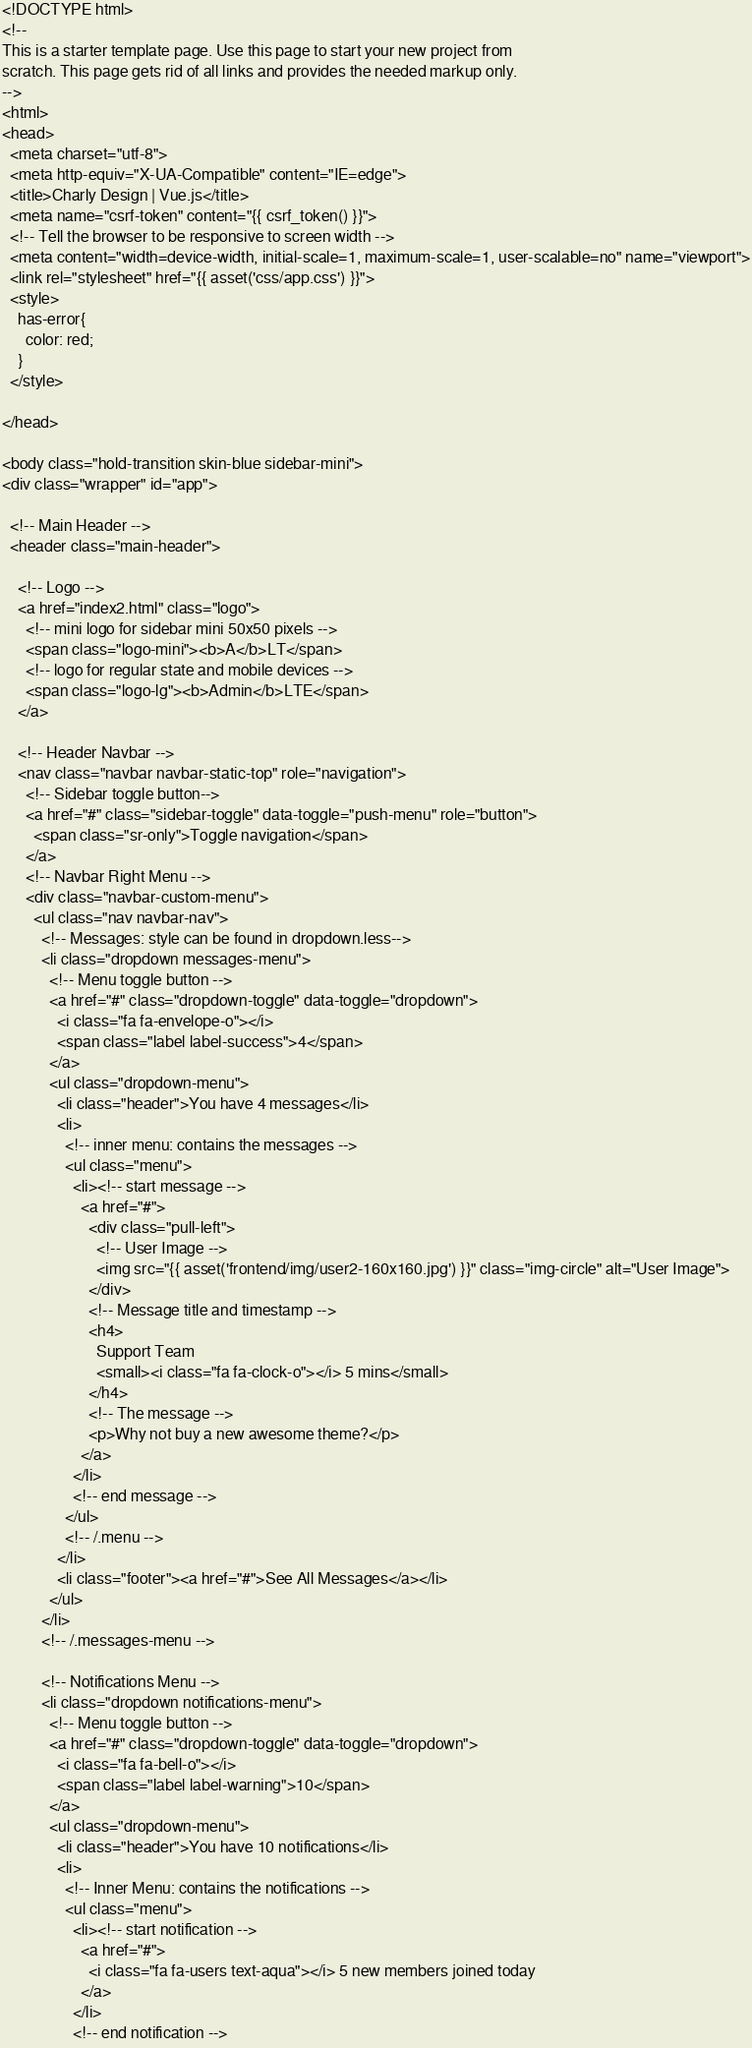<code> <loc_0><loc_0><loc_500><loc_500><_PHP_><!DOCTYPE html>
<!--
This is a starter template page. Use this page to start your new project from
scratch. This page gets rid of all links and provides the needed markup only.
-->
<html>
<head>
  <meta charset="utf-8">
  <meta http-equiv="X-UA-Compatible" content="IE=edge">
  <title>Charly Design | Vue.js</title>
  <meta name="csrf-token" content="{{ csrf_token() }}">
  <!-- Tell the browser to be responsive to screen width -->
  <meta content="width=device-width, initial-scale=1, maximum-scale=1, user-scalable=no" name="viewport">
  <link rel="stylesheet" href="{{ asset('css/app.css') }}">
  <style>
    has-error{
      color: red;
    }
  </style>
  
</head>

<body class="hold-transition skin-blue sidebar-mini">
<div class="wrapper" id="app">

  <!-- Main Header -->
  <header class="main-header">

    <!-- Logo -->
    <a href="index2.html" class="logo">
      <!-- mini logo for sidebar mini 50x50 pixels -->
      <span class="logo-mini"><b>A</b>LT</span>
      <!-- logo for regular state and mobile devices -->
      <span class="logo-lg"><b>Admin</b>LTE</span>
    </a>

    <!-- Header Navbar -->
    <nav class="navbar navbar-static-top" role="navigation">
      <!-- Sidebar toggle button-->
      <a href="#" class="sidebar-toggle" data-toggle="push-menu" role="button">
        <span class="sr-only">Toggle navigation</span>
      </a>
      <!-- Navbar Right Menu -->
      <div class="navbar-custom-menu">
        <ul class="nav navbar-nav">
          <!-- Messages: style can be found in dropdown.less-->
          <li class="dropdown messages-menu">
            <!-- Menu toggle button -->
            <a href="#" class="dropdown-toggle" data-toggle="dropdown">
              <i class="fa fa-envelope-o"></i>
              <span class="label label-success">4</span>
            </a>
            <ul class="dropdown-menu">
              <li class="header">You have 4 messages</li>
              <li>
                <!-- inner menu: contains the messages -->
                <ul class="menu">
                  <li><!-- start message -->
                    <a href="#">
                      <div class="pull-left">
                        <!-- User Image -->
                        <img src="{{ asset('frontend/img/user2-160x160.jpg') }}" class="img-circle" alt="User Image">
                      </div>
                      <!-- Message title and timestamp -->
                      <h4>
                        Support Team
                        <small><i class="fa fa-clock-o"></i> 5 mins</small>
                      </h4>
                      <!-- The message -->
                      <p>Why not buy a new awesome theme?</p>
                    </a>
                  </li>
                  <!-- end message -->
                </ul>
                <!-- /.menu -->
              </li>
              <li class="footer"><a href="#">See All Messages</a></li>
            </ul>
          </li>
          <!-- /.messages-menu -->

          <!-- Notifications Menu -->
          <li class="dropdown notifications-menu">
            <!-- Menu toggle button -->
            <a href="#" class="dropdown-toggle" data-toggle="dropdown">
              <i class="fa fa-bell-o"></i>
              <span class="label label-warning">10</span>
            </a>
            <ul class="dropdown-menu">
              <li class="header">You have 10 notifications</li>
              <li>
                <!-- Inner Menu: contains the notifications -->
                <ul class="menu">
                  <li><!-- start notification -->
                    <a href="#">
                      <i class="fa fa-users text-aqua"></i> 5 new members joined today
                    </a>
                  </li>
                  <!-- end notification --></code> 